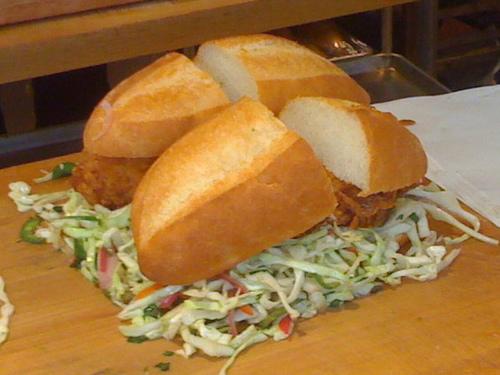Are the sandwiches sliced in half?
Quick response, please. Yes. What is this sandwich made of?
Write a very short answer. Coleslaw. How many sandwich pieces are there?
Answer briefly. 4. How many sandwiches are pictured?
Concise answer only. 2. 